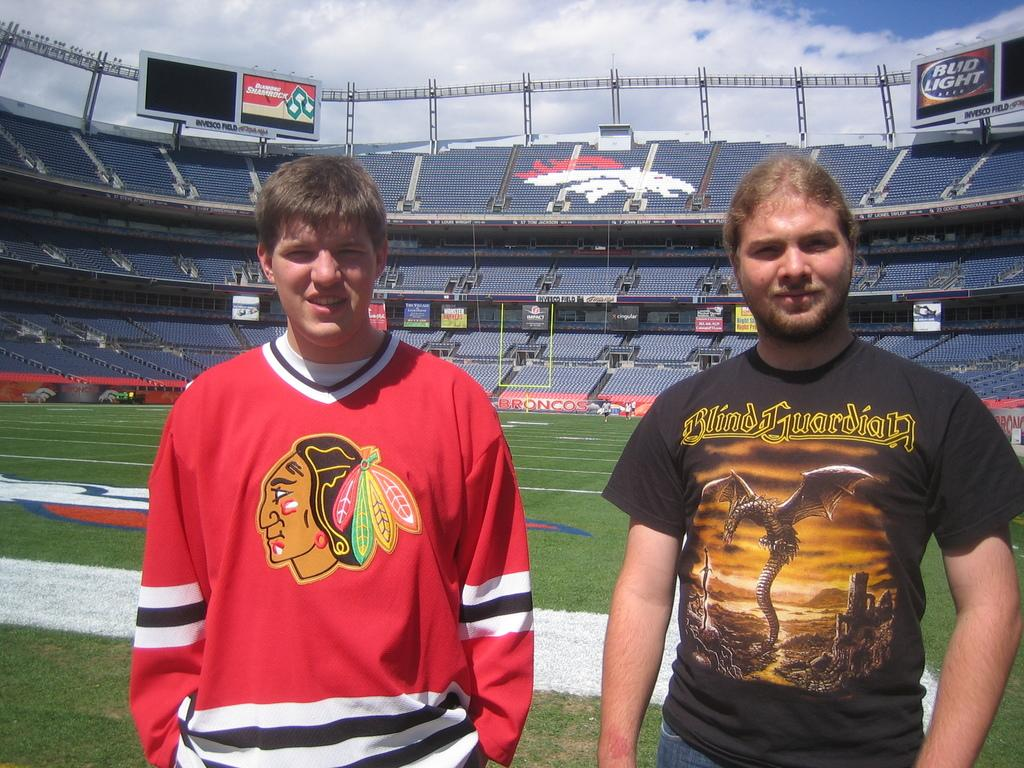<image>
Offer a succinct explanation of the picture presented. A man is in a Blind Guardian shirt at a stadium. 